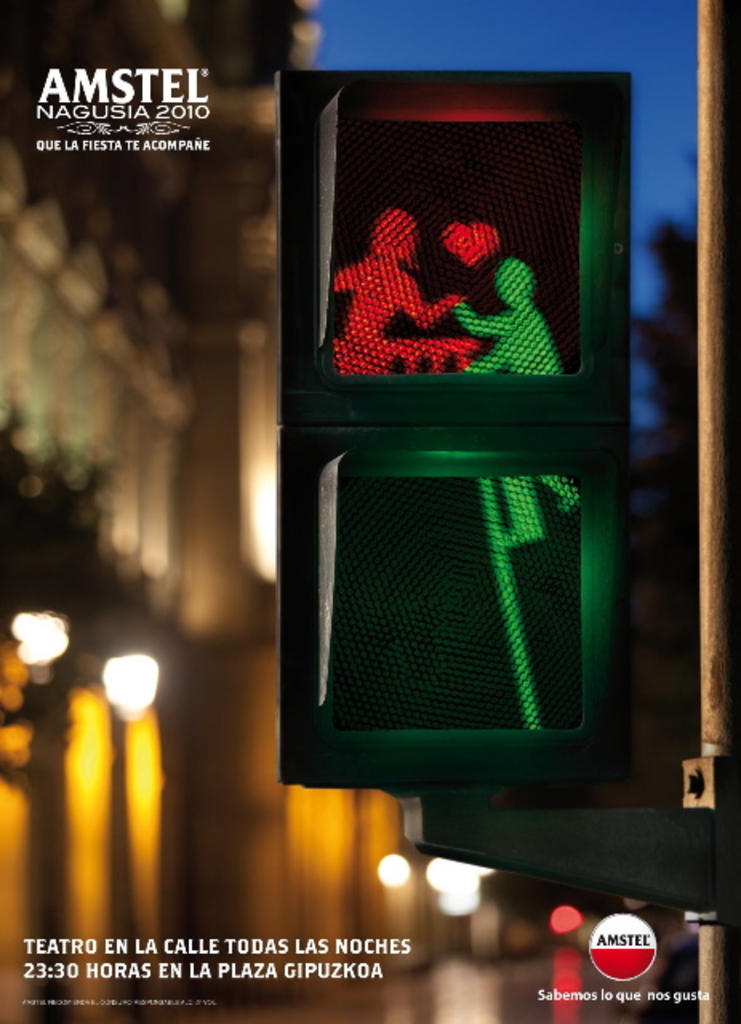Can you explain what is written at the bottom of the advertisement and its significance? The text at the bottom of the advertisement reads, 'Theater on the street every night at 23:30 in Plaza Gipuzkoa.' This indicates that the event features night-time street performances sponsored by Amstel, emphasizing Amstel's role in enhancing local culture and entertainment. 